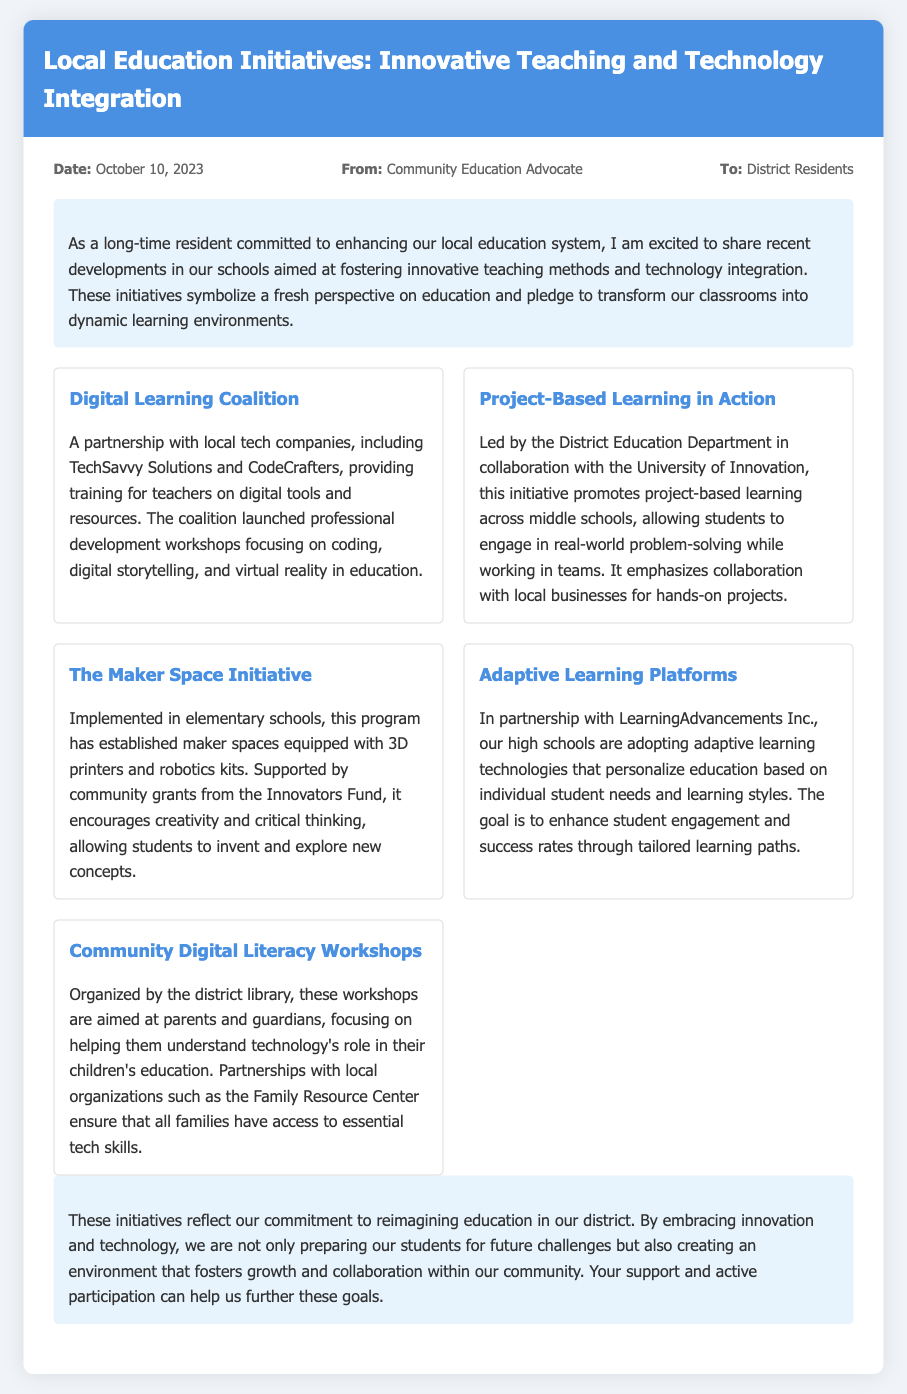what is the date of the memo? The date of the memo is clearly stated at the top, indicating when the document was composed.
Answer: October 10, 2023 who is the author of the memo? The author's name is provided in the "From" section of the memo header.
Answer: Community Education Advocate what is the title of the first initiative mentioned? The title of the first initiative is listed in a section dedicated to describing various initiatives aimed at improving education.
Answer: Digital Learning Coalition which organization is collaborating on the Project-Based Learning initiative? The collaboration details for the initiative are noted in its description, mentioning the partner organization involved.
Answer: University of Innovation how many initiatives are listed in the memo? The total number of initiatives can be counted based on their presentation in the initiatives section.
Answer: Five what is the goal of the Adaptive Learning Platforms initiative? The purpose of the initiative is described in terms of its intended outcomes for students, providing insights into its objectives.
Answer: Personalize education why is it important to engage local businesses in educational projects? The initiative emphasizes the necessity of this collaboration for hands-on experiences, highlighting its significance in education.
Answer: Real-world problem-solving what role do parents and guardians play in the Community Digital Literacy Workshops? The workshops are targeted at a specific audience, underscoring the involvement of this group in the context of technology education.
Answer: Understanding technology 